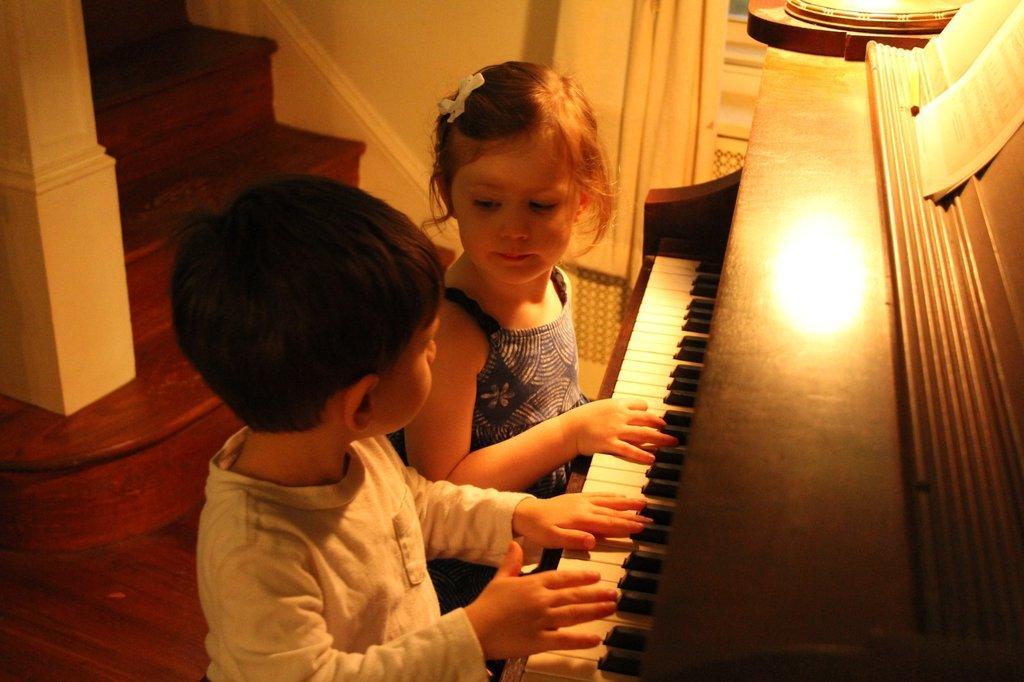Please provide a concise description of this image. In this picture we can see a boy and girl playing piano and on piano we can see papers and at back of them we have steps and beside to them there is curtain to window. 